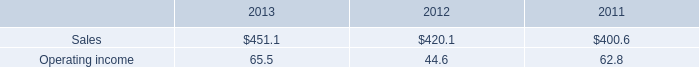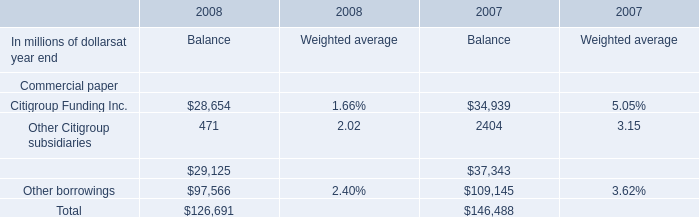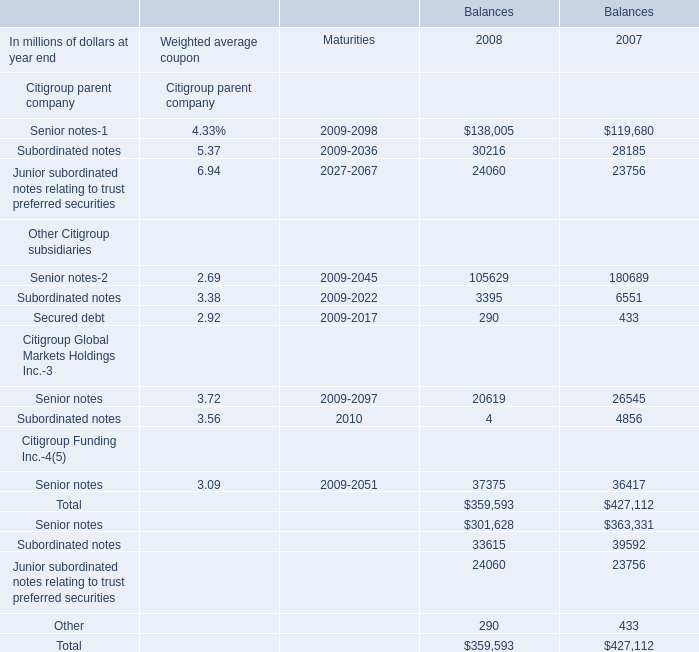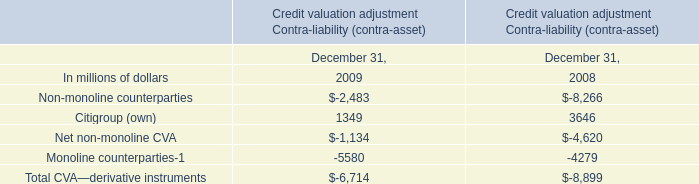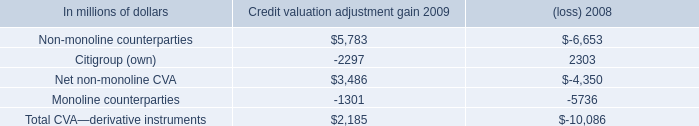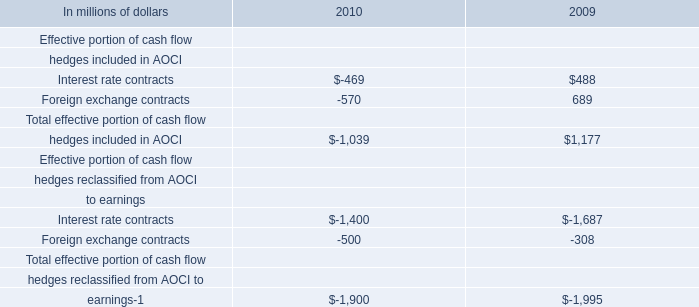What is the total amount of Senior notes Citigroup Global Markets Holdings Inc. of Balances 2007, and Citigroup Funding Inc. of 2008 Balance ? 
Computations: (26545.0 + 28654.0)
Answer: 55199.0. 